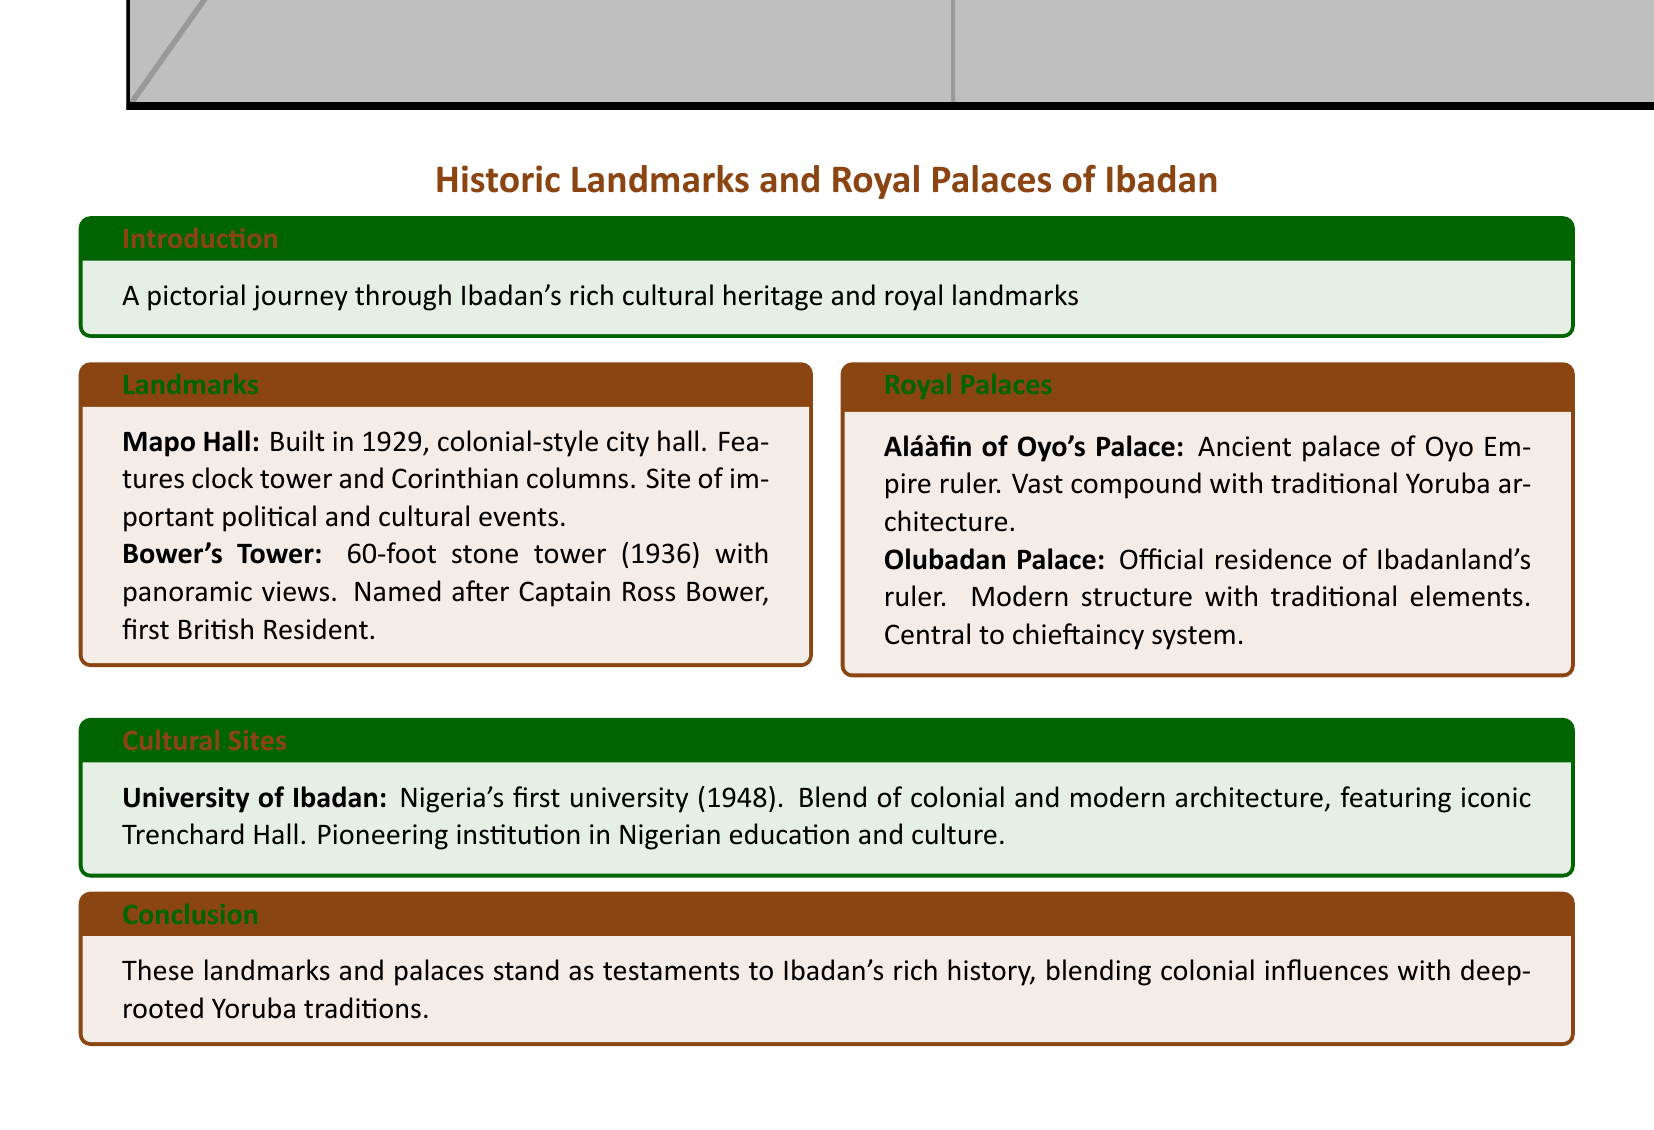What year was Mapo Hall built? The document states that Mapo Hall was built in 1929.
Answer: 1929 What is the height of Bower's Tower? The document mentions Bower's Tower as a 60-foot tower.
Answer: 60-foot What style is Mapo Hall designed in? According to the document, Mapo Hall is designed in colonial style.
Answer: colonial What is the official residence of Ibadanland's ruler? The document refers to the Olubadan Palace as the official residence.
Answer: Olubadan Palace What significant year did the University of Ibadan establish? The document indicates that the University of Ibadan was established in 1948.
Answer: 1948 How many columns does Mapo Hall feature? The document does not specify the exact number of columns in Mapo Hall, but mentions it has Corinthian columns.
Answer: Corinthian columns What is central to the chieftaincy system in Ibadan? The document states that the Olubadan Palace is central to the chieftaincy system.
Answer: Olubadan Palace Which landmark offers panoramic views? The document states that Bower's Tower offers panoramic views.
Answer: Bower's Tower What architectural blend does the University of Ibadan showcase? The document describes the University of Ibadan as a blend of colonial and modern architecture.
Answer: colonial and modern architecture 